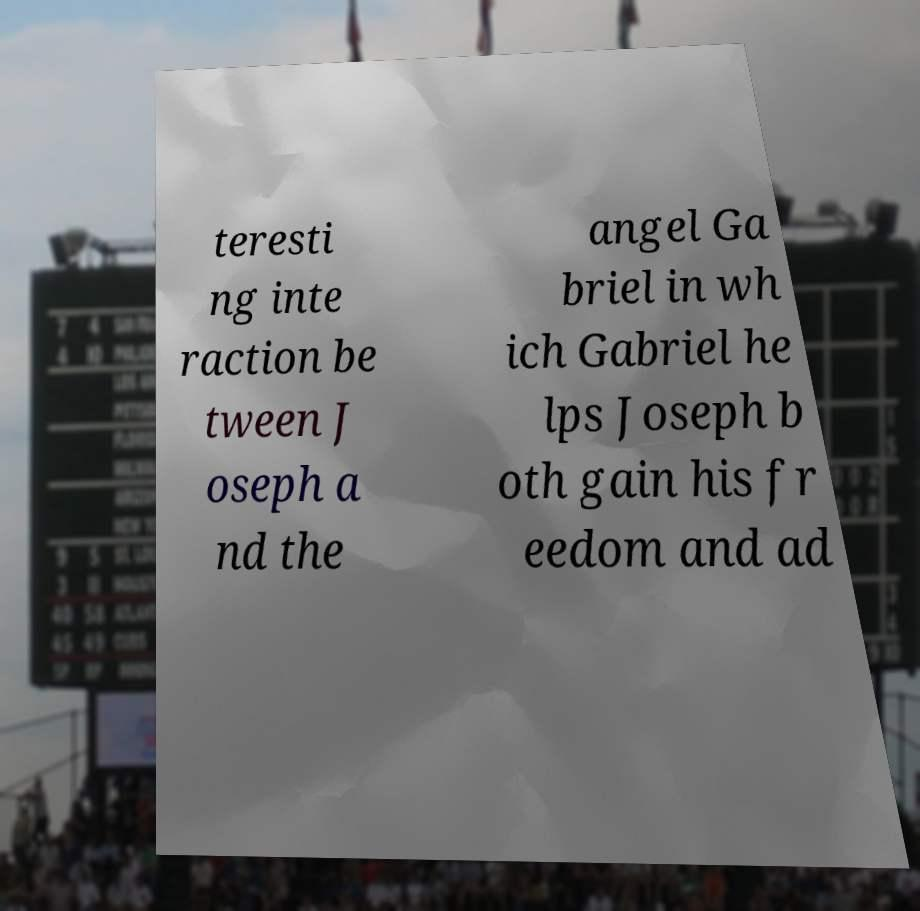Could you extract and type out the text from this image? teresti ng inte raction be tween J oseph a nd the angel Ga briel in wh ich Gabriel he lps Joseph b oth gain his fr eedom and ad 